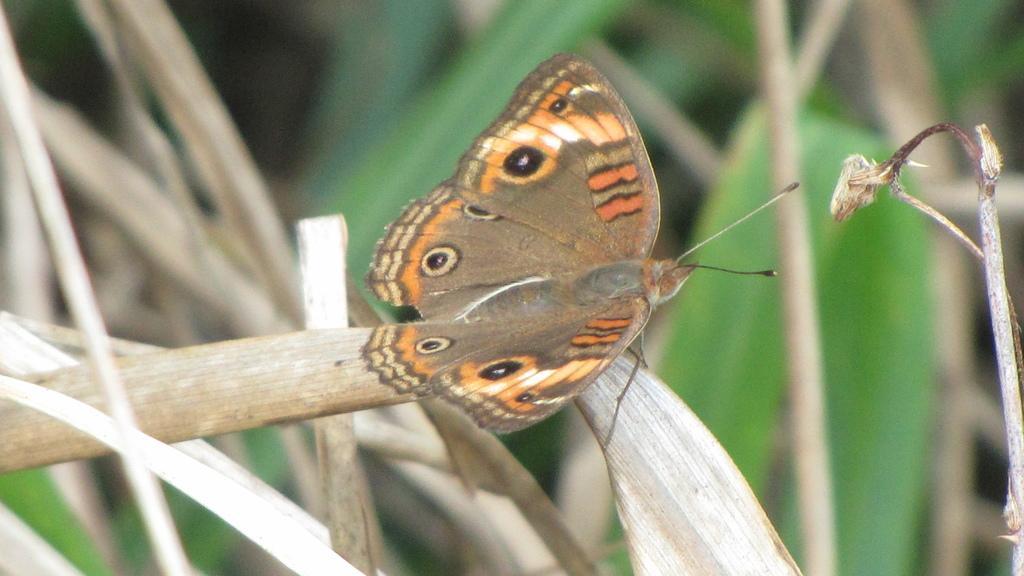In one or two sentences, can you explain what this image depicts? There is a butterfly on the dry leaves in the foreground area of the image. 